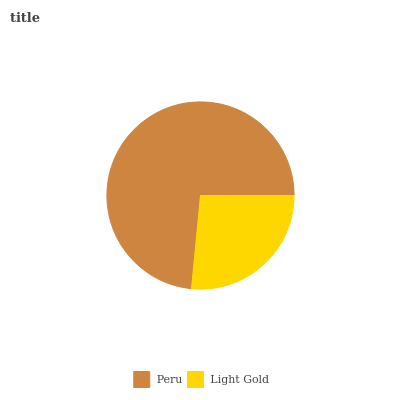Is Light Gold the minimum?
Answer yes or no. Yes. Is Peru the maximum?
Answer yes or no. Yes. Is Light Gold the maximum?
Answer yes or no. No. Is Peru greater than Light Gold?
Answer yes or no. Yes. Is Light Gold less than Peru?
Answer yes or no. Yes. Is Light Gold greater than Peru?
Answer yes or no. No. Is Peru less than Light Gold?
Answer yes or no. No. Is Peru the high median?
Answer yes or no. Yes. Is Light Gold the low median?
Answer yes or no. Yes. Is Light Gold the high median?
Answer yes or no. No. Is Peru the low median?
Answer yes or no. No. 